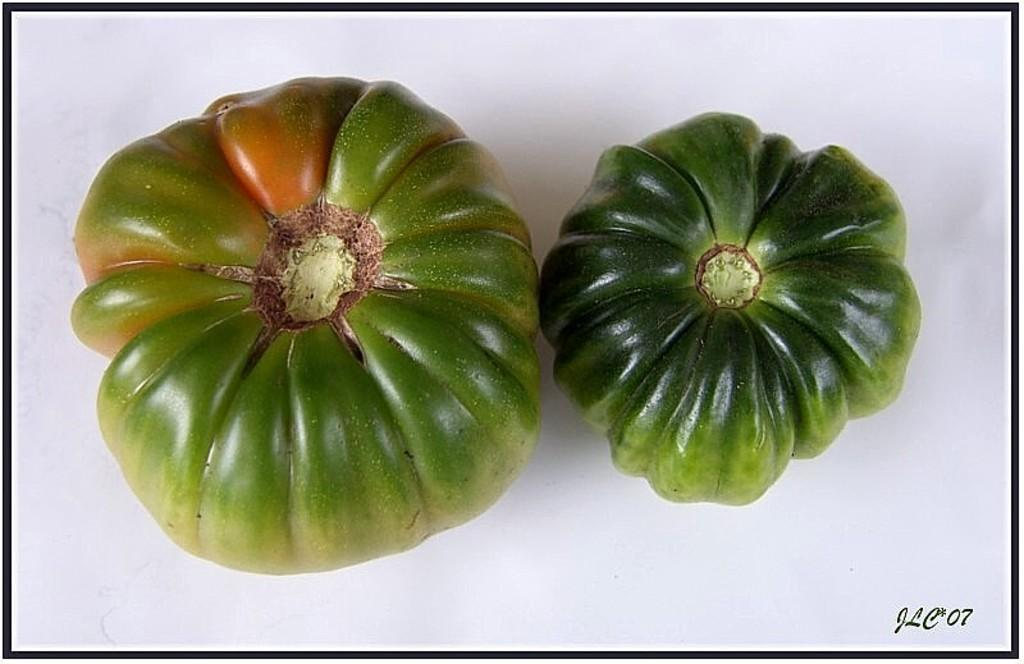What type of food is visible on the white surface in the image? There are vegetables on a white surface in the image. Where can a watermark be found in the image? A watermark can be found in the right side bottom corner of the image. What color are the borders of the image? The image has black color borders. What type of meat is being shared among friends in the image? There is no meat or friends present in the image; it only features vegetables on a white surface with a watermark and black borders. 